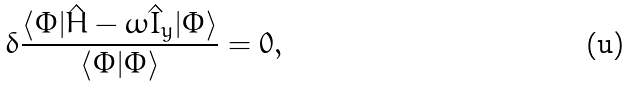<formula> <loc_0><loc_0><loc_500><loc_500>\delta \frac { \langle \Phi | \hat { H } - \omega \hat { I } _ { y } | \Phi \rangle } { \langle \Phi | \Phi \rangle } = 0 ,</formula> 